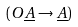<formula> <loc_0><loc_0><loc_500><loc_500>( O \underline { A } \rightarrow \underline { A } )</formula> 